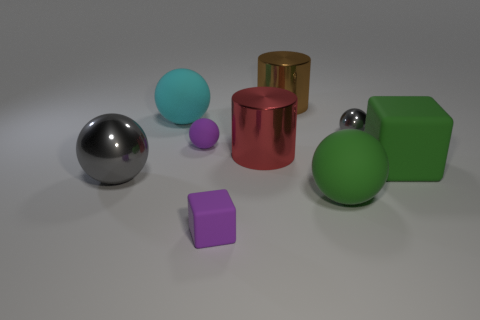Subtract 2 spheres. How many spheres are left? 3 Subtract all large gray balls. How many balls are left? 4 Subtract all yellow spheres. Subtract all green cubes. How many spheres are left? 5 Subtract all spheres. How many objects are left? 4 Subtract 1 brown cylinders. How many objects are left? 8 Subtract all big objects. Subtract all tiny blue matte balls. How many objects are left? 3 Add 5 red cylinders. How many red cylinders are left? 6 Add 1 big green rubber things. How many big green rubber things exist? 3 